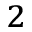<formula> <loc_0><loc_0><loc_500><loc_500>_ { 2 }</formula> 